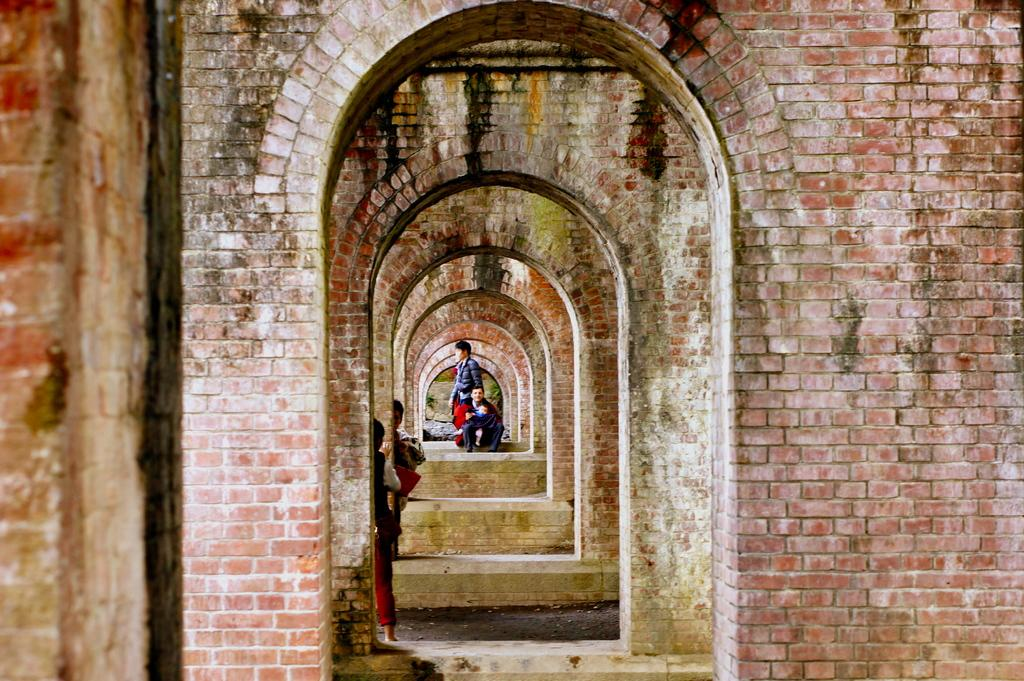What type of architectural structure is visible in the image? There is an architectural structure with many walls and arches in the image. Can you describe the people in the image? There is a group of people in the image. What other items can be seen in the image besides the architectural structure and people? There are other unspecified items in the image. How many seeds can be seen growing on the arm of the person in the image? There are no seeds or arms visible in the image; it features an architectural structure and a group of people. What type of bears are interacting with the people in the image? There are no bears present in the image; it only features an architectural structure and a group of people. 